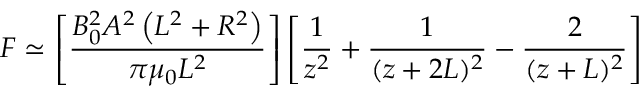<formula> <loc_0><loc_0><loc_500><loc_500>F \simeq \left [ { \frac { B _ { 0 } ^ { 2 } A ^ { 2 } \left ( L ^ { 2 } + R ^ { 2 } \right ) } { \pi \mu _ { 0 } L ^ { 2 } } } \right ] \left [ { \frac { 1 } { z ^ { 2 } } } + { \frac { 1 } { ( z + 2 L ) ^ { 2 } } } - { \frac { 2 } { ( z + L ) ^ { 2 } } } \right ]</formula> 